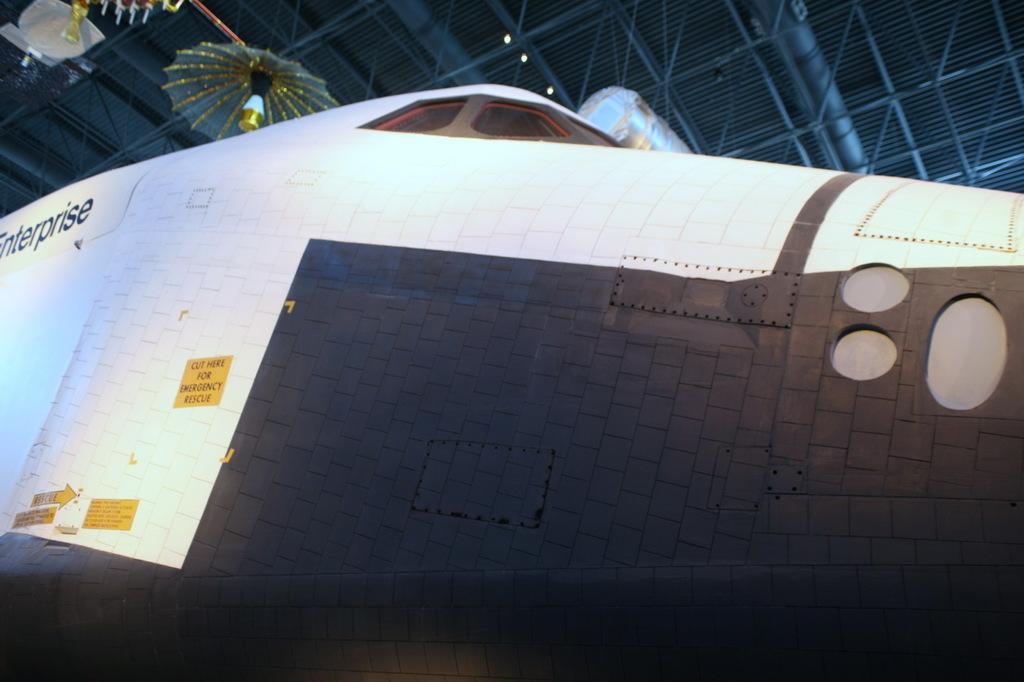How would you summarize this image in a sentence or two? In this picture we can see an airplane with stickers on it and in the background we can see an umbrella on roof top. 